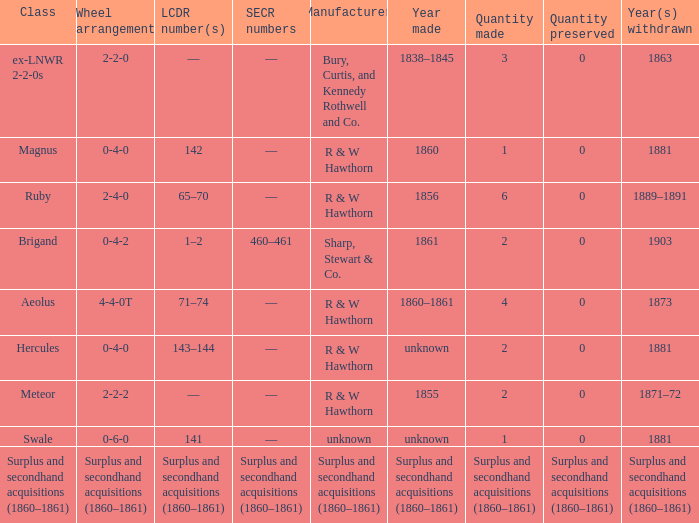What was the SECR number of the item made in 1861? 460–461. 